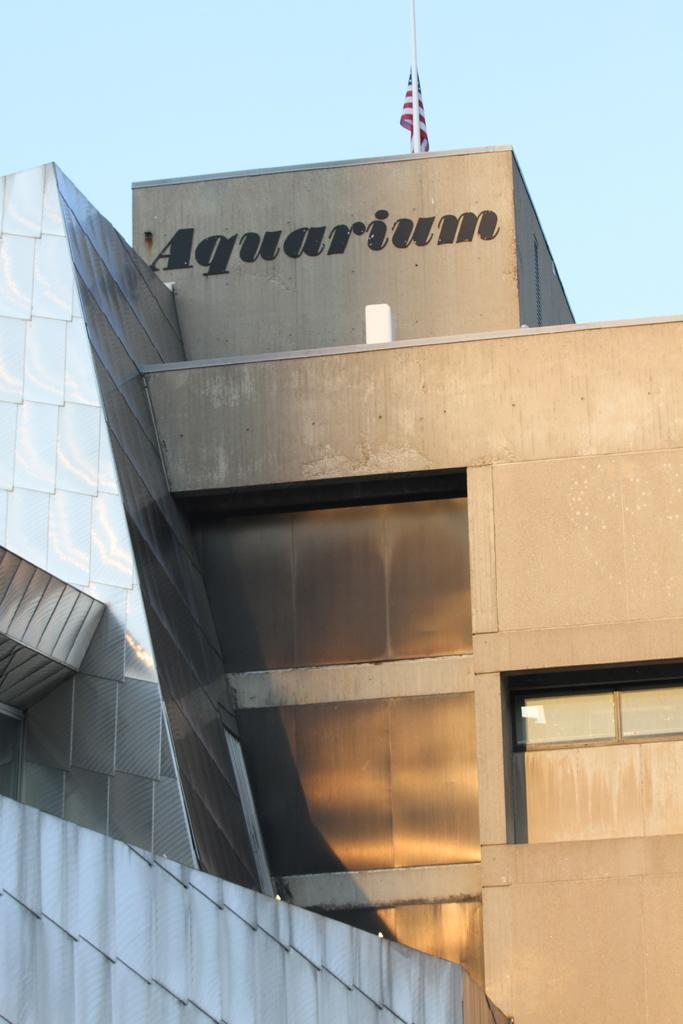Provide a one-sentence caption for the provided image. Concert building with American Flag at the top along with the word Aquarium. 